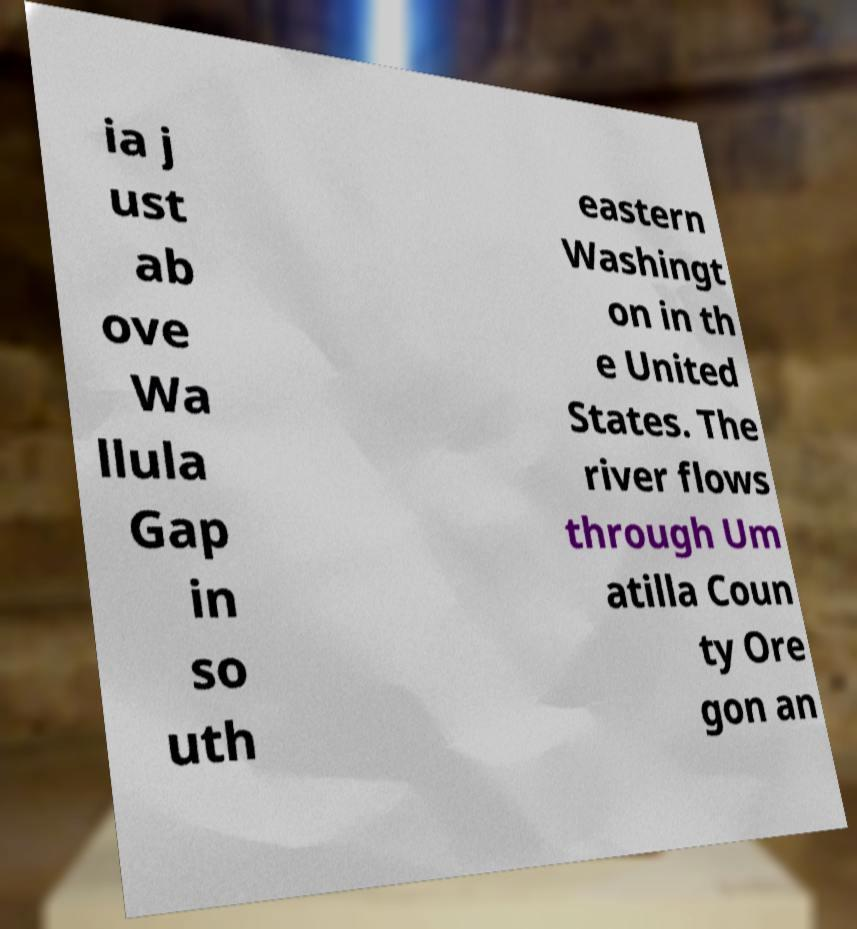Please identify and transcribe the text found in this image. ia j ust ab ove Wa llula Gap in so uth eastern Washingt on in th e United States. The river flows through Um atilla Coun ty Ore gon an 